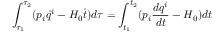<formula> <loc_0><loc_0><loc_500><loc_500>\int _ { \tau _ { 1 } } ^ { \tau _ { 2 } } ( p _ { i } \dot { q } ^ { i } - H _ { 0 } \dot { t } ) d \tau = \int _ { t _ { 1 } } ^ { t _ { 2 } } ( p _ { i } \frac { d q ^ { i } } { d t } - H _ { 0 } ) d t</formula> 